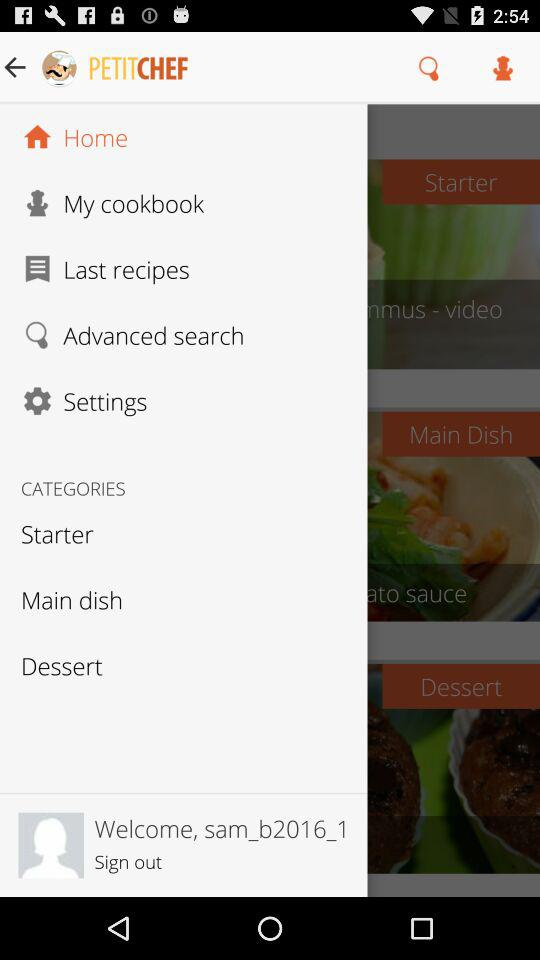What is the username? The username is "sam_b2016_1". 